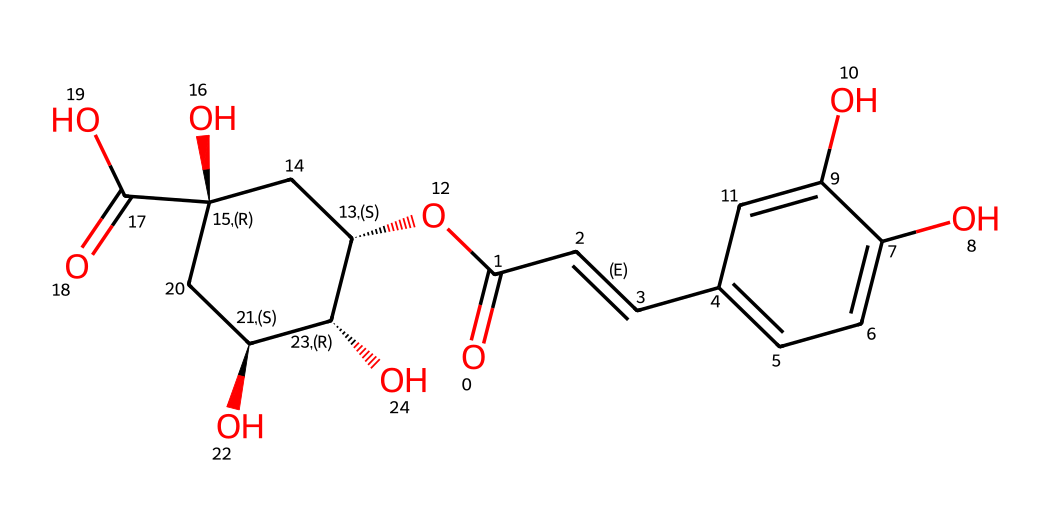What is the common name of this compound? This chemical structure corresponds to chlorogenic acid, a well-known compound found in coffee beans. The inquiry looks for the name, which is a characteristic identifier for this medicinal compound.
Answer: chlorogenic acid How many hydroxyl groups are present in this molecule? Upon analyzing the structure, we can observe multiple -OH groups, specifically two hydroxyl groups located on the aromatic ring. Counting these reveals a total of two.
Answer: two What type of chemical structure does chlorogenic acid have? Chlorogenic acid exhibits a polyphenolic structure due to the presence of phenol rings and multiple hydroxyl groups. This classification arises from its ability to donate protons and form complexes with various substances, characteristic of polyphenols.
Answer: polyphenol What is the molecular formula of chlorogenic acid? The molecular formula can be derived from the structure by counting the atoms of each element: carbon (C), hydrogen (H), and oxygen (O). After analyzing the SMILES representation, the total is C16H18O9.
Answer: C16H18O9 In which part of the structure is the ketone functional group located? The ketone functional group is identified by the carbonyl group (C=O) found at the beginning of the structure. This element indicates the presence of a carbon bonded to oxygen with a double bond, typical of ketones.
Answer: at the beginning Which part of the molecule is responsible for its antioxidant properties? The presence of multiple hydroxyl groups (-OH) is key, as these groups are known to scavenge free radicals, contributing to the antioxidant properties of chlorogenic acid. By interacting with oxidants, these groups protect cellular structures from damage.
Answer: hydroxyl groups What is the total number of rings present in this compound? Scanning the structure for cyclic components shows one aromatic ring and one aliphatic ring, leading to a total of two rings present in the overall molecular structure.
Answer: two 